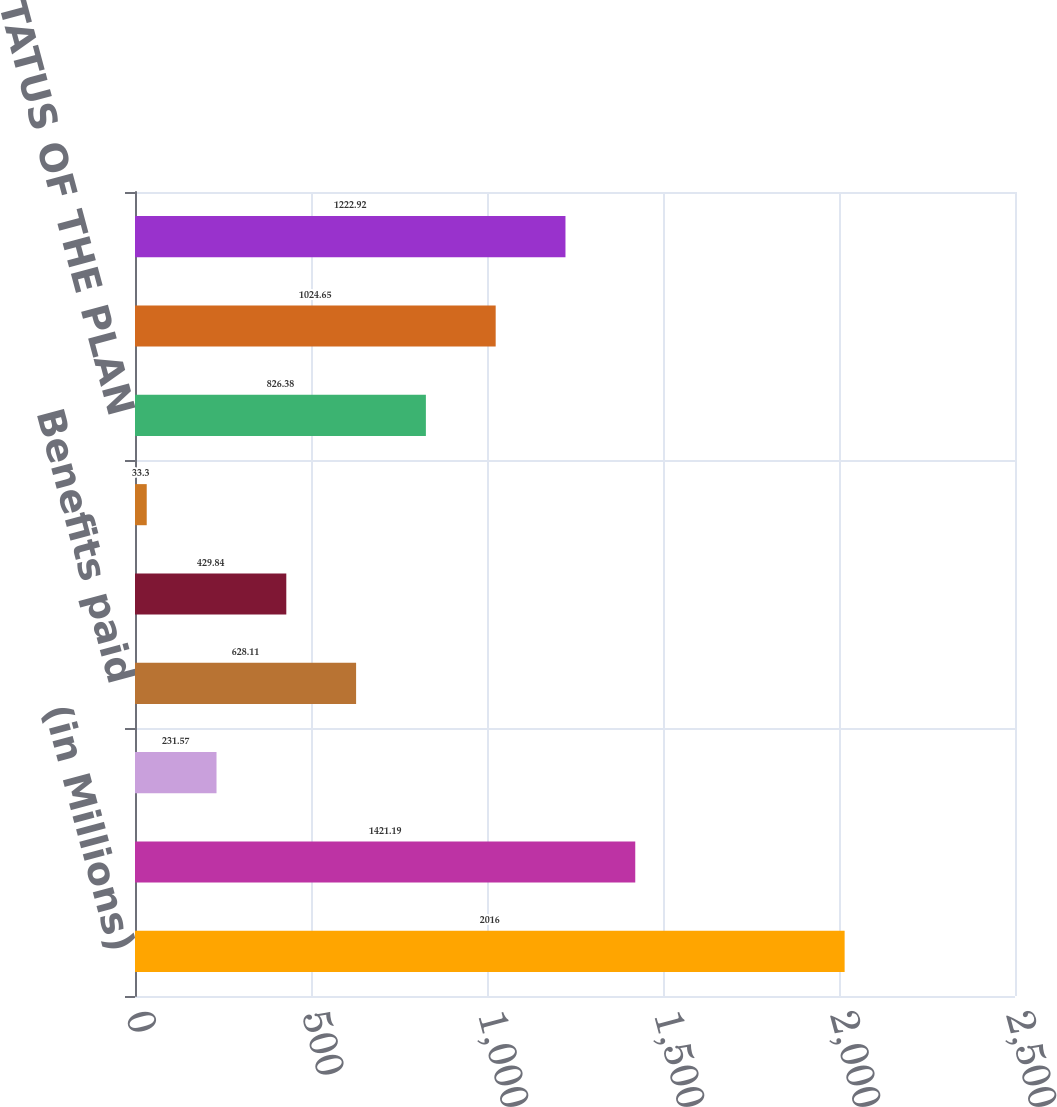<chart> <loc_0><loc_0><loc_500><loc_500><bar_chart><fcel>(in Millions)<fcel>Projected benefit obligation<fcel>Interest cost<fcel>Benefits paid<fcel>Company contributions<fcel>US plans without assets<fcel>NET FUNDED STATUS OF THE PLAN<fcel>Accrued benefit liability (2)<fcel>TOTAL<nl><fcel>2016<fcel>1421.19<fcel>231.57<fcel>628.11<fcel>429.84<fcel>33.3<fcel>826.38<fcel>1024.65<fcel>1222.92<nl></chart> 